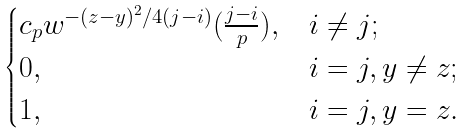<formula> <loc_0><loc_0><loc_500><loc_500>\begin{cases} c _ { p } w ^ { - ( z - y ) ^ { 2 } / 4 ( j - i ) } ( \frac { j - i } { p } ) , & i \neq j ; \\ 0 , & i = j , y \neq z ; \\ 1 , & i = j , y = z . \end{cases}</formula> 